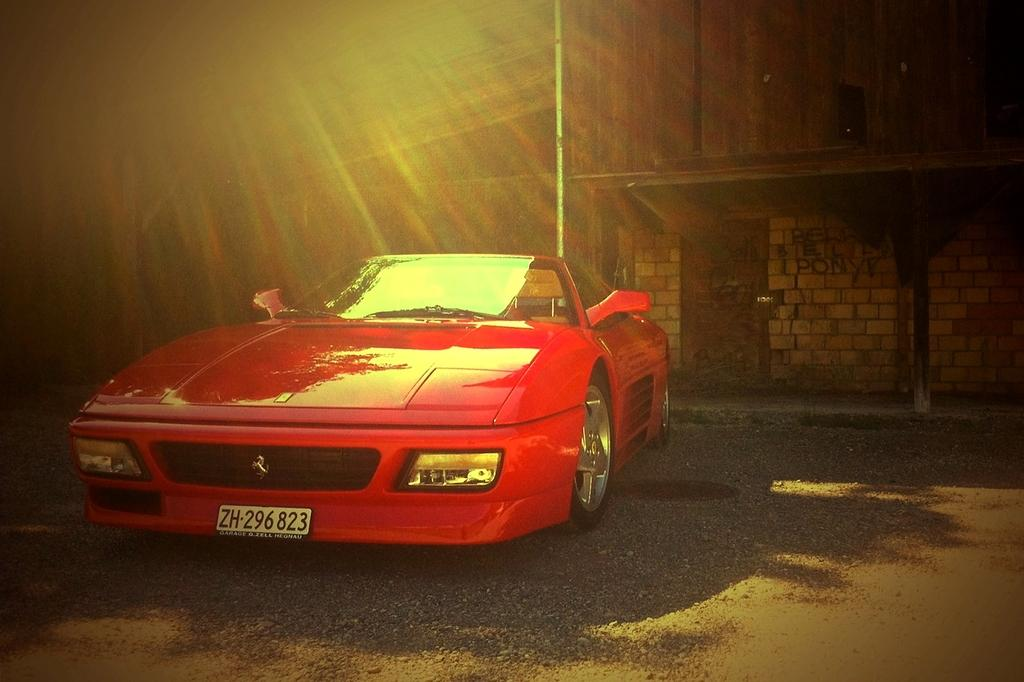What color is the car in the image? The car in the image is red. Where is the car located in the image? The car is parked on the road. What can be seen behind the car in the image? There is a building behind the car. What is the weather like in the image? The sunshine rays falling on the car suggest that it is a sunny day. What topic are the students discussing in the image? There are no students or discussion present in the image; it features a red car parked on the road with a building in the background. 